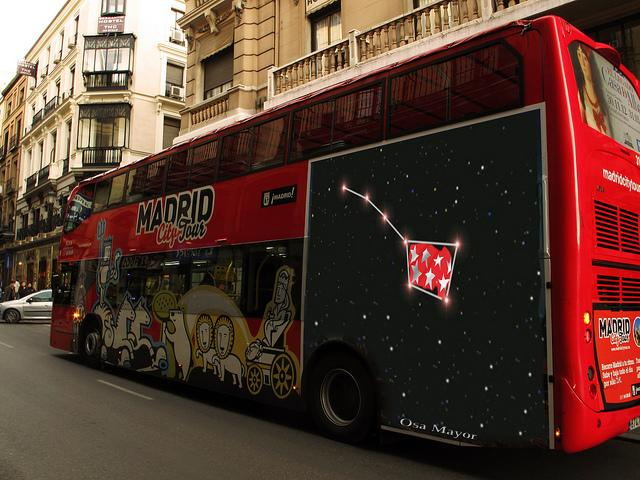What is this constellation often called in English? Please explain your reasoning. big dipper. The constellation looks like a big dipper. 